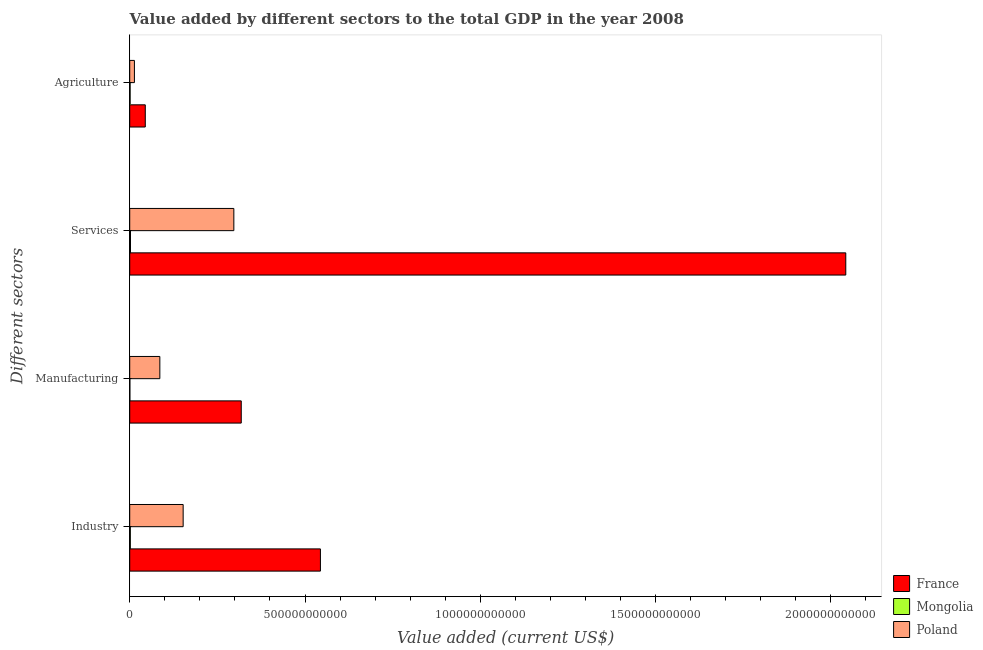How many groups of bars are there?
Keep it short and to the point. 4. Are the number of bars on each tick of the Y-axis equal?
Give a very brief answer. Yes. What is the label of the 2nd group of bars from the top?
Provide a succinct answer. Services. What is the value added by industrial sector in Mongolia?
Your response must be concise. 1.73e+09. Across all countries, what is the maximum value added by agricultural sector?
Ensure brevity in your answer.  4.44e+1. Across all countries, what is the minimum value added by manufacturing sector?
Offer a very short reply. 3.69e+08. In which country was the value added by manufacturing sector minimum?
Make the answer very short. Mongolia. What is the total value added by industrial sector in the graph?
Provide a succinct answer. 6.98e+11. What is the difference between the value added by agricultural sector in Mongolia and that in Poland?
Keep it short and to the point. -1.23e+1. What is the difference between the value added by industrial sector in Mongolia and the value added by services sector in France?
Ensure brevity in your answer.  -2.04e+12. What is the average value added by agricultural sector per country?
Your response must be concise. 1.96e+1. What is the difference between the value added by manufacturing sector and value added by industrial sector in France?
Your answer should be very brief. -2.26e+11. In how many countries, is the value added by services sector greater than 2000000000000 US$?
Offer a very short reply. 1. What is the ratio of the value added by industrial sector in Poland to that in France?
Keep it short and to the point. 0.28. Is the value added by manufacturing sector in France less than that in Mongolia?
Your answer should be compact. No. What is the difference between the highest and the second highest value added by agricultural sector?
Provide a succinct answer. 3.10e+1. What is the difference between the highest and the lowest value added by agricultural sector?
Provide a short and direct response. 4.33e+1. In how many countries, is the value added by agricultural sector greater than the average value added by agricultural sector taken over all countries?
Ensure brevity in your answer.  1. Is it the case that in every country, the sum of the value added by services sector and value added by manufacturing sector is greater than the sum of value added by agricultural sector and value added by industrial sector?
Give a very brief answer. No. What does the 2nd bar from the top in Manufacturing represents?
Ensure brevity in your answer.  Mongolia. What does the 2nd bar from the bottom in Services represents?
Offer a terse response. Mongolia. How many bars are there?
Provide a succinct answer. 12. Are all the bars in the graph horizontal?
Ensure brevity in your answer.  Yes. How many countries are there in the graph?
Ensure brevity in your answer.  3. What is the difference between two consecutive major ticks on the X-axis?
Provide a succinct answer. 5.00e+11. Are the values on the major ticks of X-axis written in scientific E-notation?
Provide a short and direct response. No. Where does the legend appear in the graph?
Provide a short and direct response. Bottom right. How many legend labels are there?
Provide a short and direct response. 3. How are the legend labels stacked?
Your answer should be compact. Vertical. What is the title of the graph?
Give a very brief answer. Value added by different sectors to the total GDP in the year 2008. What is the label or title of the X-axis?
Keep it short and to the point. Value added (current US$). What is the label or title of the Y-axis?
Make the answer very short. Different sectors. What is the Value added (current US$) of France in Industry?
Your response must be concise. 5.44e+11. What is the Value added (current US$) of Mongolia in Industry?
Offer a terse response. 1.73e+09. What is the Value added (current US$) in Poland in Industry?
Offer a terse response. 1.52e+11. What is the Value added (current US$) of France in Manufacturing?
Offer a very short reply. 3.18e+11. What is the Value added (current US$) of Mongolia in Manufacturing?
Give a very brief answer. 3.69e+08. What is the Value added (current US$) of Poland in Manufacturing?
Your answer should be very brief. 8.59e+1. What is the Value added (current US$) in France in Services?
Offer a terse response. 2.04e+12. What is the Value added (current US$) of Mongolia in Services?
Offer a terse response. 2.23e+09. What is the Value added (current US$) in Poland in Services?
Provide a succinct answer. 2.97e+11. What is the Value added (current US$) in France in Agriculture?
Your answer should be compact. 4.44e+1. What is the Value added (current US$) of Mongolia in Agriculture?
Keep it short and to the point. 1.08e+09. What is the Value added (current US$) in Poland in Agriculture?
Your answer should be compact. 1.34e+1. Across all Different sectors, what is the maximum Value added (current US$) of France?
Offer a very short reply. 2.04e+12. Across all Different sectors, what is the maximum Value added (current US$) in Mongolia?
Your response must be concise. 2.23e+09. Across all Different sectors, what is the maximum Value added (current US$) of Poland?
Provide a succinct answer. 2.97e+11. Across all Different sectors, what is the minimum Value added (current US$) of France?
Offer a very short reply. 4.44e+1. Across all Different sectors, what is the minimum Value added (current US$) in Mongolia?
Make the answer very short. 3.69e+08. Across all Different sectors, what is the minimum Value added (current US$) of Poland?
Ensure brevity in your answer.  1.34e+1. What is the total Value added (current US$) in France in the graph?
Give a very brief answer. 2.95e+12. What is the total Value added (current US$) of Mongolia in the graph?
Your answer should be very brief. 5.42e+09. What is the total Value added (current US$) in Poland in the graph?
Make the answer very short. 5.49e+11. What is the difference between the Value added (current US$) of France in Industry and that in Manufacturing?
Offer a terse response. 2.26e+11. What is the difference between the Value added (current US$) in Mongolia in Industry and that in Manufacturing?
Make the answer very short. 1.37e+09. What is the difference between the Value added (current US$) of Poland in Industry and that in Manufacturing?
Provide a short and direct response. 6.65e+1. What is the difference between the Value added (current US$) in France in Industry and that in Services?
Give a very brief answer. -1.50e+12. What is the difference between the Value added (current US$) of Mongolia in Industry and that in Services?
Make the answer very short. -4.96e+08. What is the difference between the Value added (current US$) in Poland in Industry and that in Services?
Your answer should be very brief. -1.45e+11. What is the difference between the Value added (current US$) in France in Industry and that in Agriculture?
Offer a very short reply. 5.00e+11. What is the difference between the Value added (current US$) in Mongolia in Industry and that in Agriculture?
Give a very brief answer. 6.54e+08. What is the difference between the Value added (current US$) of Poland in Industry and that in Agriculture?
Provide a succinct answer. 1.39e+11. What is the difference between the Value added (current US$) in France in Manufacturing and that in Services?
Provide a short and direct response. -1.72e+12. What is the difference between the Value added (current US$) of Mongolia in Manufacturing and that in Services?
Make the answer very short. -1.86e+09. What is the difference between the Value added (current US$) in Poland in Manufacturing and that in Services?
Offer a terse response. -2.11e+11. What is the difference between the Value added (current US$) in France in Manufacturing and that in Agriculture?
Provide a short and direct response. 2.74e+11. What is the difference between the Value added (current US$) in Mongolia in Manufacturing and that in Agriculture?
Keep it short and to the point. -7.12e+08. What is the difference between the Value added (current US$) in Poland in Manufacturing and that in Agriculture?
Offer a terse response. 7.25e+1. What is the difference between the Value added (current US$) in France in Services and that in Agriculture?
Your answer should be very brief. 2.00e+12. What is the difference between the Value added (current US$) in Mongolia in Services and that in Agriculture?
Your response must be concise. 1.15e+09. What is the difference between the Value added (current US$) in Poland in Services and that in Agriculture?
Give a very brief answer. 2.84e+11. What is the difference between the Value added (current US$) of France in Industry and the Value added (current US$) of Mongolia in Manufacturing?
Your answer should be compact. 5.44e+11. What is the difference between the Value added (current US$) of France in Industry and the Value added (current US$) of Poland in Manufacturing?
Ensure brevity in your answer.  4.58e+11. What is the difference between the Value added (current US$) of Mongolia in Industry and the Value added (current US$) of Poland in Manufacturing?
Provide a short and direct response. -8.42e+1. What is the difference between the Value added (current US$) of France in Industry and the Value added (current US$) of Mongolia in Services?
Your answer should be very brief. 5.42e+11. What is the difference between the Value added (current US$) in France in Industry and the Value added (current US$) in Poland in Services?
Your answer should be very brief. 2.47e+11. What is the difference between the Value added (current US$) in Mongolia in Industry and the Value added (current US$) in Poland in Services?
Offer a very short reply. -2.95e+11. What is the difference between the Value added (current US$) of France in Industry and the Value added (current US$) of Mongolia in Agriculture?
Offer a terse response. 5.43e+11. What is the difference between the Value added (current US$) of France in Industry and the Value added (current US$) of Poland in Agriculture?
Your response must be concise. 5.31e+11. What is the difference between the Value added (current US$) of Mongolia in Industry and the Value added (current US$) of Poland in Agriculture?
Keep it short and to the point. -1.17e+1. What is the difference between the Value added (current US$) of France in Manufacturing and the Value added (current US$) of Mongolia in Services?
Offer a very short reply. 3.16e+11. What is the difference between the Value added (current US$) in France in Manufacturing and the Value added (current US$) in Poland in Services?
Ensure brevity in your answer.  2.11e+1. What is the difference between the Value added (current US$) of Mongolia in Manufacturing and the Value added (current US$) of Poland in Services?
Keep it short and to the point. -2.97e+11. What is the difference between the Value added (current US$) in France in Manufacturing and the Value added (current US$) in Mongolia in Agriculture?
Give a very brief answer. 3.17e+11. What is the difference between the Value added (current US$) of France in Manufacturing and the Value added (current US$) of Poland in Agriculture?
Ensure brevity in your answer.  3.05e+11. What is the difference between the Value added (current US$) of Mongolia in Manufacturing and the Value added (current US$) of Poland in Agriculture?
Your answer should be very brief. -1.30e+1. What is the difference between the Value added (current US$) of France in Services and the Value added (current US$) of Mongolia in Agriculture?
Offer a terse response. 2.04e+12. What is the difference between the Value added (current US$) of France in Services and the Value added (current US$) of Poland in Agriculture?
Your answer should be very brief. 2.03e+12. What is the difference between the Value added (current US$) of Mongolia in Services and the Value added (current US$) of Poland in Agriculture?
Offer a very short reply. -1.12e+1. What is the average Value added (current US$) in France per Different sectors?
Make the answer very short. 7.37e+11. What is the average Value added (current US$) of Mongolia per Different sectors?
Offer a terse response. 1.35e+09. What is the average Value added (current US$) in Poland per Different sectors?
Your answer should be very brief. 1.37e+11. What is the difference between the Value added (current US$) of France and Value added (current US$) of Mongolia in Industry?
Provide a short and direct response. 5.42e+11. What is the difference between the Value added (current US$) of France and Value added (current US$) of Poland in Industry?
Offer a terse response. 3.92e+11. What is the difference between the Value added (current US$) of Mongolia and Value added (current US$) of Poland in Industry?
Provide a short and direct response. -1.51e+11. What is the difference between the Value added (current US$) of France and Value added (current US$) of Mongolia in Manufacturing?
Ensure brevity in your answer.  3.18e+11. What is the difference between the Value added (current US$) in France and Value added (current US$) in Poland in Manufacturing?
Your response must be concise. 2.32e+11. What is the difference between the Value added (current US$) in Mongolia and Value added (current US$) in Poland in Manufacturing?
Keep it short and to the point. -8.56e+1. What is the difference between the Value added (current US$) of France and Value added (current US$) of Mongolia in Services?
Your answer should be compact. 2.04e+12. What is the difference between the Value added (current US$) in France and Value added (current US$) in Poland in Services?
Offer a terse response. 1.75e+12. What is the difference between the Value added (current US$) in Mongolia and Value added (current US$) in Poland in Services?
Provide a succinct answer. -2.95e+11. What is the difference between the Value added (current US$) in France and Value added (current US$) in Mongolia in Agriculture?
Provide a succinct answer. 4.33e+1. What is the difference between the Value added (current US$) in France and Value added (current US$) in Poland in Agriculture?
Ensure brevity in your answer.  3.10e+1. What is the difference between the Value added (current US$) in Mongolia and Value added (current US$) in Poland in Agriculture?
Your answer should be compact. -1.23e+1. What is the ratio of the Value added (current US$) of France in Industry to that in Manufacturing?
Offer a very short reply. 1.71. What is the ratio of the Value added (current US$) of Mongolia in Industry to that in Manufacturing?
Provide a short and direct response. 4.7. What is the ratio of the Value added (current US$) in Poland in Industry to that in Manufacturing?
Provide a short and direct response. 1.77. What is the ratio of the Value added (current US$) of France in Industry to that in Services?
Ensure brevity in your answer.  0.27. What is the ratio of the Value added (current US$) in Mongolia in Industry to that in Services?
Your answer should be very brief. 0.78. What is the ratio of the Value added (current US$) of Poland in Industry to that in Services?
Your answer should be very brief. 0.51. What is the ratio of the Value added (current US$) of France in Industry to that in Agriculture?
Give a very brief answer. 12.26. What is the ratio of the Value added (current US$) in Mongolia in Industry to that in Agriculture?
Make the answer very short. 1.61. What is the ratio of the Value added (current US$) in Poland in Industry to that in Agriculture?
Make the answer very short. 11.37. What is the ratio of the Value added (current US$) in France in Manufacturing to that in Services?
Keep it short and to the point. 0.16. What is the ratio of the Value added (current US$) in Mongolia in Manufacturing to that in Services?
Make the answer very short. 0.17. What is the ratio of the Value added (current US$) in Poland in Manufacturing to that in Services?
Your response must be concise. 0.29. What is the ratio of the Value added (current US$) of France in Manufacturing to that in Agriculture?
Your answer should be compact. 7.17. What is the ratio of the Value added (current US$) of Mongolia in Manufacturing to that in Agriculture?
Your answer should be very brief. 0.34. What is the ratio of the Value added (current US$) in Poland in Manufacturing to that in Agriculture?
Keep it short and to the point. 6.41. What is the ratio of the Value added (current US$) of France in Services to that in Agriculture?
Offer a very short reply. 46.03. What is the ratio of the Value added (current US$) of Mongolia in Services to that in Agriculture?
Your response must be concise. 2.06. What is the ratio of the Value added (current US$) of Poland in Services to that in Agriculture?
Keep it short and to the point. 22.15. What is the difference between the highest and the second highest Value added (current US$) in France?
Your response must be concise. 1.50e+12. What is the difference between the highest and the second highest Value added (current US$) of Mongolia?
Your response must be concise. 4.96e+08. What is the difference between the highest and the second highest Value added (current US$) of Poland?
Ensure brevity in your answer.  1.45e+11. What is the difference between the highest and the lowest Value added (current US$) of France?
Ensure brevity in your answer.  2.00e+12. What is the difference between the highest and the lowest Value added (current US$) of Mongolia?
Give a very brief answer. 1.86e+09. What is the difference between the highest and the lowest Value added (current US$) in Poland?
Keep it short and to the point. 2.84e+11. 